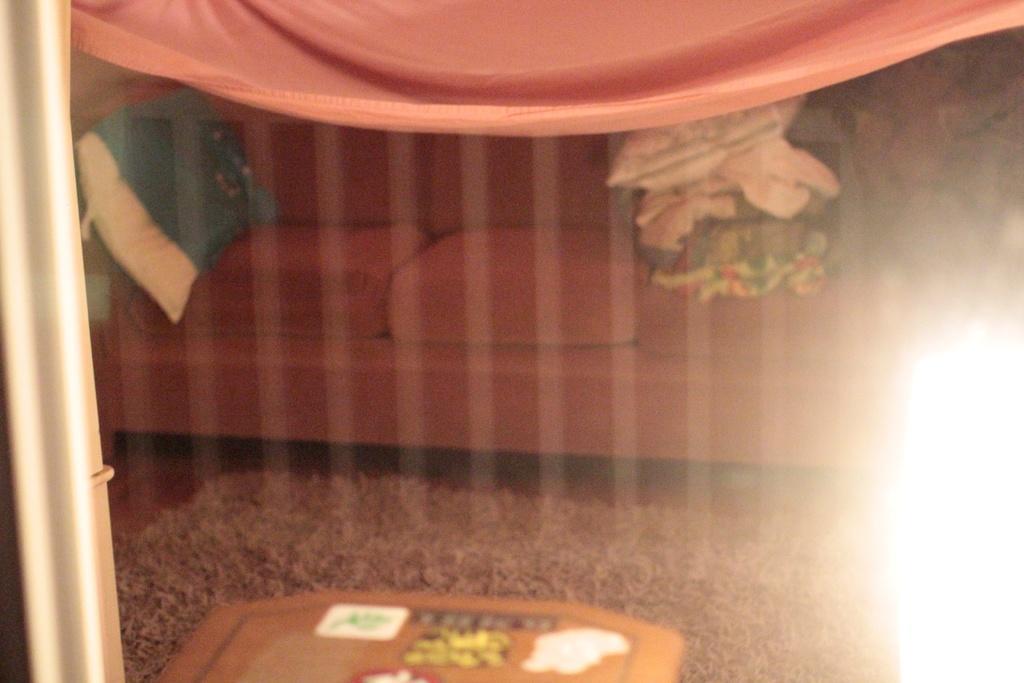How would you summarize this image in a sentence or two? In this image there is a sofa on a floor and there is a mat, at the top there are cloths. 